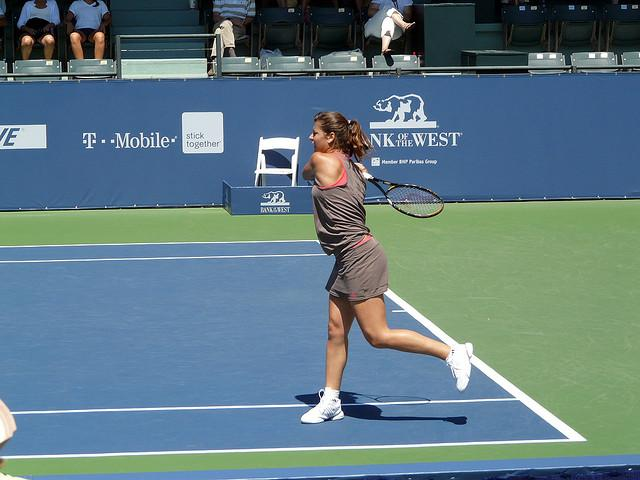What is the middle advertisement on the blue wall about? Please explain your reasoning. cellular service. The advertisement is for the company t-mobile. 